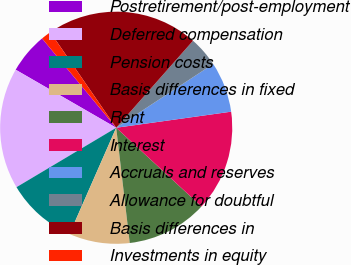Convert chart to OTSL. <chart><loc_0><loc_0><loc_500><loc_500><pie_chart><fcel>Postretirement/post-employment<fcel>Deferred compensation<fcel>Pension costs<fcel>Basis differences in fixed<fcel>Rent<fcel>Interest<fcel>Accruals and reserves<fcel>Allowance for doubtful<fcel>Basis differences in<fcel>Investments in equity<nl><fcel>5.64%<fcel>16.89%<fcel>9.86%<fcel>8.45%<fcel>11.27%<fcel>14.08%<fcel>7.05%<fcel>4.23%<fcel>21.12%<fcel>1.42%<nl></chart> 